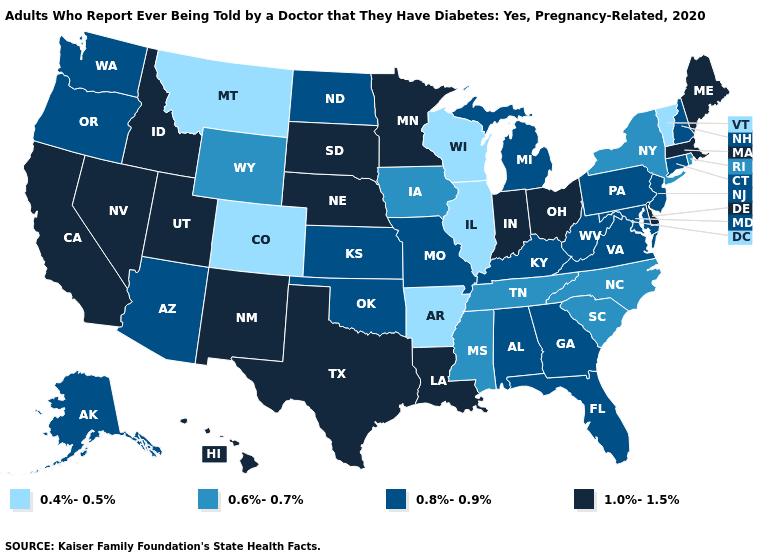What is the value of Hawaii?
Answer briefly. 1.0%-1.5%. What is the value of Ohio?
Be succinct. 1.0%-1.5%. Does New Hampshire have the same value as Nevada?
Give a very brief answer. No. What is the lowest value in states that border South Dakota?
Short answer required. 0.4%-0.5%. Does Texas have the same value as Maine?
Answer briefly. Yes. What is the highest value in the USA?
Be succinct. 1.0%-1.5%. Does Illinois have the lowest value in the MidWest?
Give a very brief answer. Yes. Name the states that have a value in the range 0.8%-0.9%?
Quick response, please. Alabama, Alaska, Arizona, Connecticut, Florida, Georgia, Kansas, Kentucky, Maryland, Michigan, Missouri, New Hampshire, New Jersey, North Dakota, Oklahoma, Oregon, Pennsylvania, Virginia, Washington, West Virginia. Name the states that have a value in the range 1.0%-1.5%?
Answer briefly. California, Delaware, Hawaii, Idaho, Indiana, Louisiana, Maine, Massachusetts, Minnesota, Nebraska, Nevada, New Mexico, Ohio, South Dakota, Texas, Utah. What is the lowest value in states that border Michigan?
Short answer required. 0.4%-0.5%. What is the lowest value in states that border Kansas?
Short answer required. 0.4%-0.5%. Name the states that have a value in the range 0.4%-0.5%?
Give a very brief answer. Arkansas, Colorado, Illinois, Montana, Vermont, Wisconsin. Which states have the highest value in the USA?
Short answer required. California, Delaware, Hawaii, Idaho, Indiana, Louisiana, Maine, Massachusetts, Minnesota, Nebraska, Nevada, New Mexico, Ohio, South Dakota, Texas, Utah. What is the highest value in the South ?
Concise answer only. 1.0%-1.5%. What is the value of Arizona?
Answer briefly. 0.8%-0.9%. 